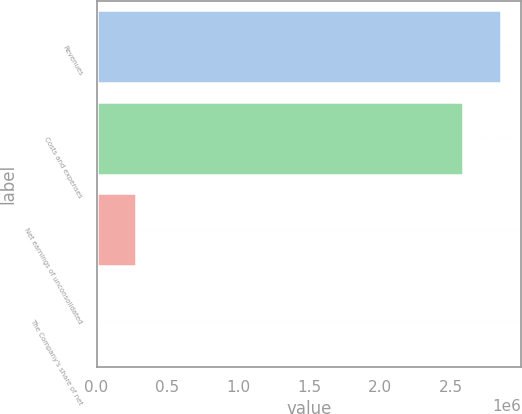Convert chart. <chart><loc_0><loc_0><loc_500><loc_500><bar_chart><fcel>Revenues<fcel>Costs and expenses<fcel>Net earnings of unconsolidated<fcel>The Company's share of net<nl><fcel>2.85214e+06<fcel>2.5882e+06<fcel>276476<fcel>12536<nl></chart> 